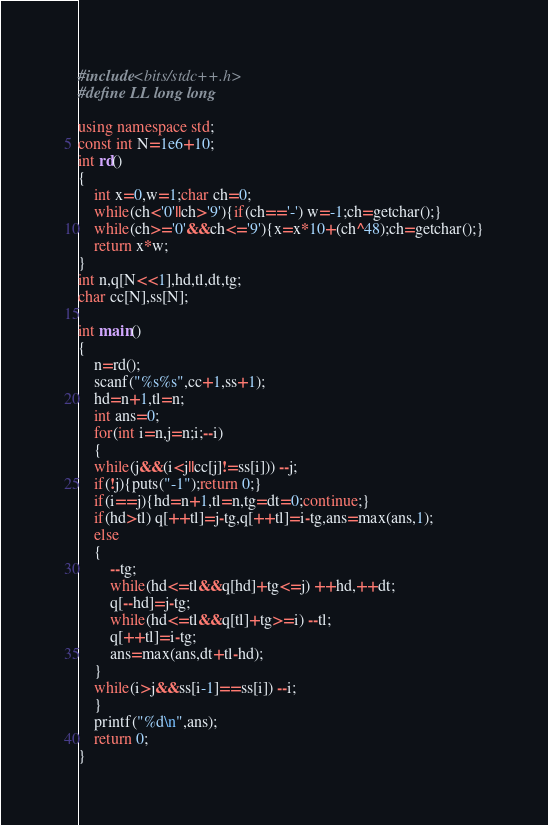<code> <loc_0><loc_0><loc_500><loc_500><_C++_>#include<bits/stdc++.h>
#define LL long long

using namespace std;
const int N=1e6+10;
int rd()
{
    int x=0,w=1;char ch=0;
    while(ch<'0'||ch>'9'){if(ch=='-') w=-1;ch=getchar();}
    while(ch>='0'&&ch<='9'){x=x*10+(ch^48);ch=getchar();}
    return x*w;
}
int n,q[N<<1],hd,tl,dt,tg;
char cc[N],ss[N];

int main()
{
    n=rd();
    scanf("%s%s",cc+1,ss+1);
    hd=n+1,tl=n;
    int ans=0;
    for(int i=n,j=n;i;--i)
    {
	while(j&&(i<j||cc[j]!=ss[i])) --j;
	if(!j){puts("-1");return 0;}
	if(i==j){hd=n+1,tl=n,tg=dt=0;continue;}
	if(hd>tl) q[++tl]=j-tg,q[++tl]=i-tg,ans=max(ans,1);
	else
	{
	    --tg;
	    while(hd<=tl&&q[hd]+tg<=j) ++hd,++dt;
	    q[--hd]=j-tg;
	    while(hd<=tl&&q[tl]+tg>=i) --tl;
	    q[++tl]=i-tg;
	    ans=max(ans,dt+tl-hd);
	}
	while(i>j&&ss[i-1]==ss[i]) --i;
    }
    printf("%d\n",ans);
    return 0;
}
</code> 